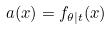<formula> <loc_0><loc_0><loc_500><loc_500>a ( x ) = f _ { \theta | t } ( x )</formula> 